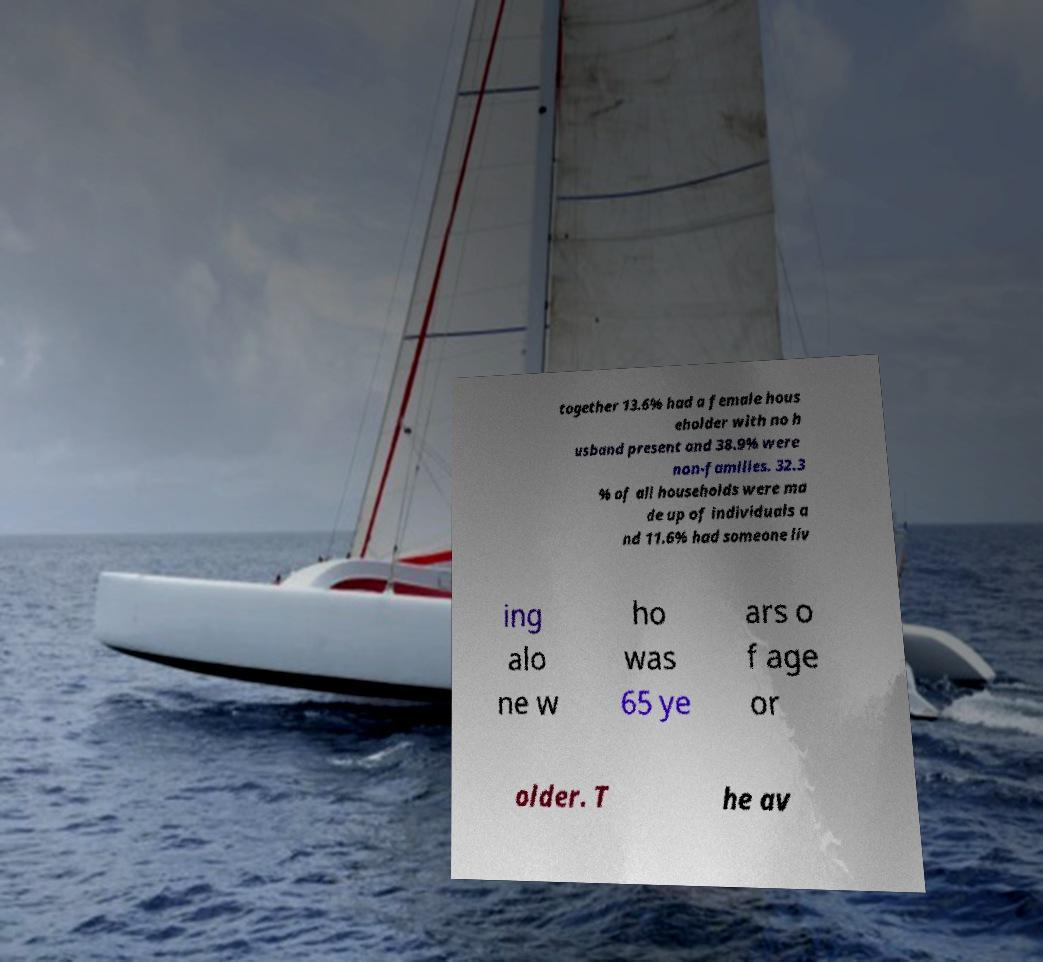Can you read and provide the text displayed in the image?This photo seems to have some interesting text. Can you extract and type it out for me? together 13.6% had a female hous eholder with no h usband present and 38.9% were non-families. 32.3 % of all households were ma de up of individuals a nd 11.6% had someone liv ing alo ne w ho was 65 ye ars o f age or older. T he av 